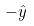<formula> <loc_0><loc_0><loc_500><loc_500>- \hat { y }</formula> 